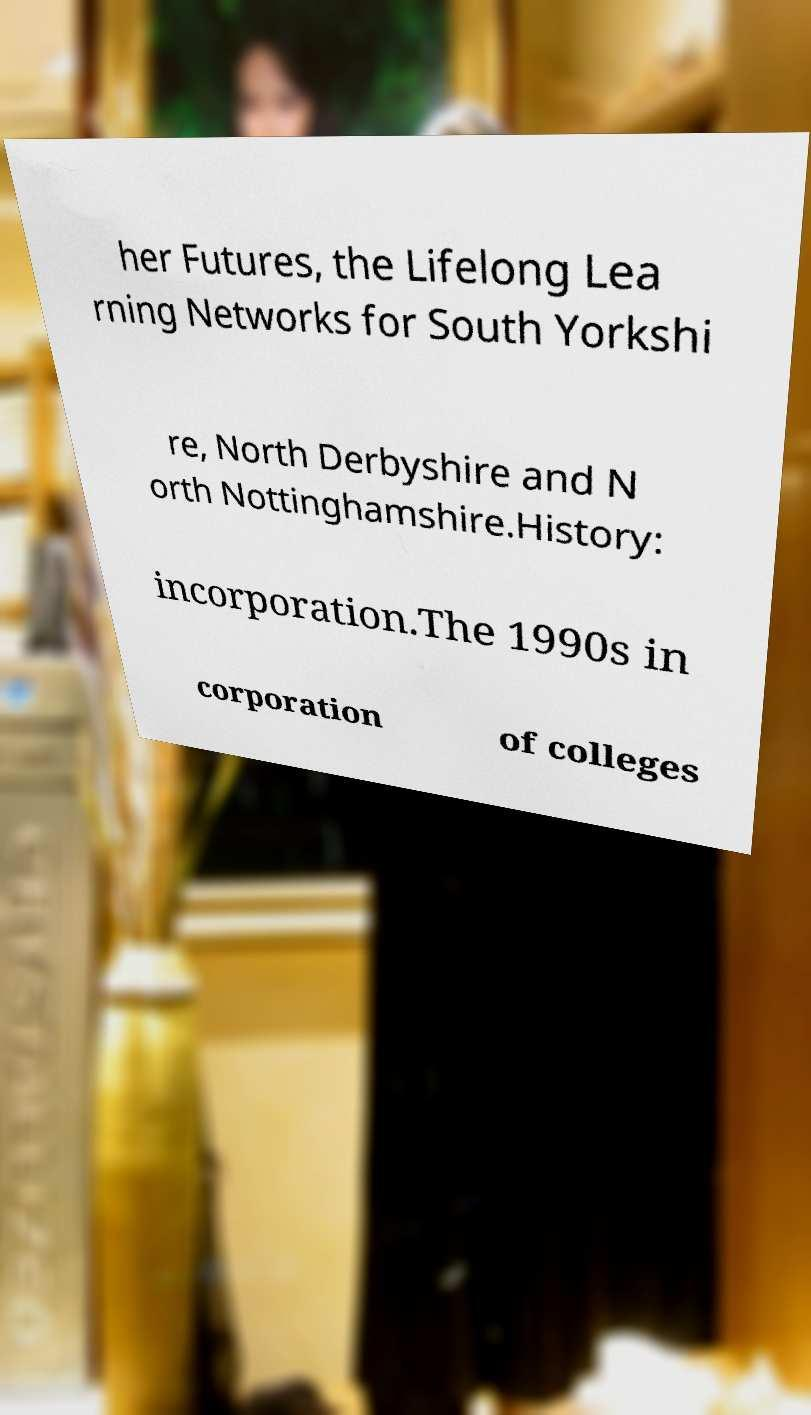Could you assist in decoding the text presented in this image and type it out clearly? her Futures, the Lifelong Lea rning Networks for South Yorkshi re, North Derbyshire and N orth Nottinghamshire.History: incorporation.The 1990s in corporation of colleges 